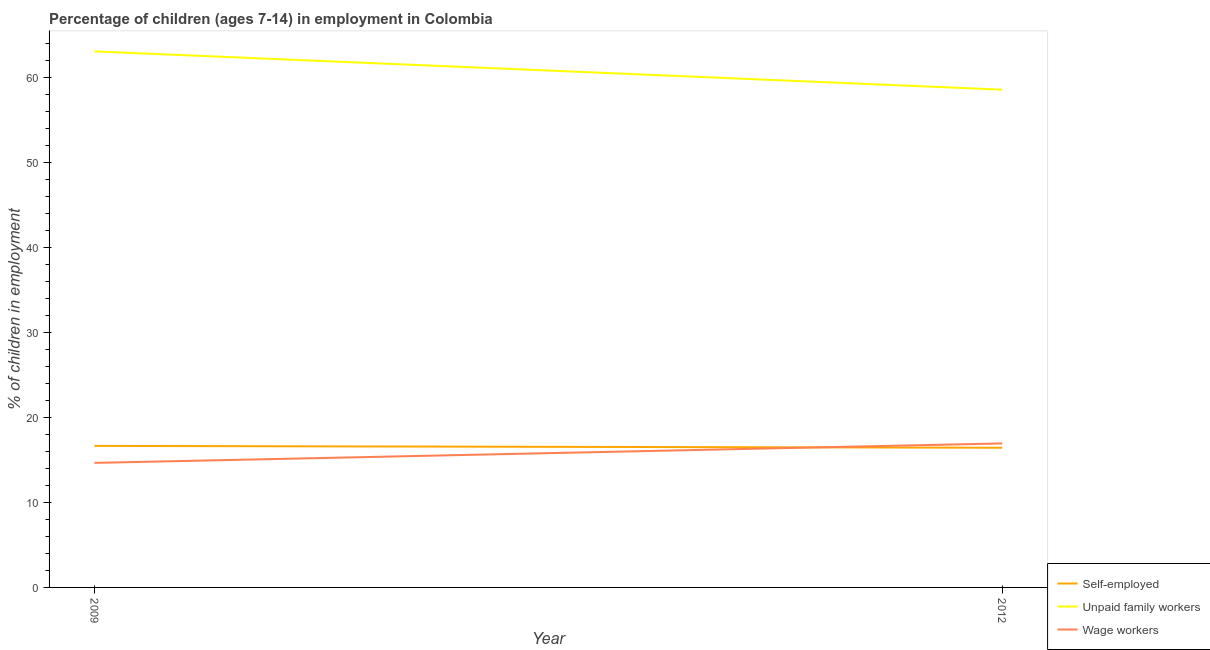Is the number of lines equal to the number of legend labels?
Provide a short and direct response. Yes. What is the percentage of self employed children in 2009?
Give a very brief answer. 16.64. Across all years, what is the maximum percentage of children employed as unpaid family workers?
Ensure brevity in your answer.  63.02. Across all years, what is the minimum percentage of children employed as unpaid family workers?
Provide a short and direct response. 58.52. What is the total percentage of children employed as unpaid family workers in the graph?
Offer a very short reply. 121.54. What is the difference between the percentage of self employed children in 2009 and that in 2012?
Your answer should be compact. 0.22. What is the difference between the percentage of children employed as wage workers in 2012 and the percentage of children employed as unpaid family workers in 2009?
Your response must be concise. -46.09. What is the average percentage of self employed children per year?
Make the answer very short. 16.53. In the year 2012, what is the difference between the percentage of children employed as unpaid family workers and percentage of children employed as wage workers?
Your response must be concise. 41.59. In how many years, is the percentage of self employed children greater than 2 %?
Your answer should be very brief. 2. What is the ratio of the percentage of children employed as wage workers in 2009 to that in 2012?
Your answer should be very brief. 0.86. Is the percentage of children employed as unpaid family workers in 2009 less than that in 2012?
Keep it short and to the point. No. Does the percentage of children employed as unpaid family workers monotonically increase over the years?
Keep it short and to the point. No. Is the percentage of children employed as wage workers strictly greater than the percentage of children employed as unpaid family workers over the years?
Give a very brief answer. No. How many years are there in the graph?
Offer a terse response. 2. Are the values on the major ticks of Y-axis written in scientific E-notation?
Keep it short and to the point. No. Does the graph contain any zero values?
Keep it short and to the point. No. Where does the legend appear in the graph?
Make the answer very short. Bottom right. How are the legend labels stacked?
Your answer should be compact. Vertical. What is the title of the graph?
Your response must be concise. Percentage of children (ages 7-14) in employment in Colombia. What is the label or title of the X-axis?
Your response must be concise. Year. What is the label or title of the Y-axis?
Your response must be concise. % of children in employment. What is the % of children in employment in Self-employed in 2009?
Your answer should be very brief. 16.64. What is the % of children in employment in Unpaid family workers in 2009?
Your answer should be very brief. 63.02. What is the % of children in employment in Wage workers in 2009?
Your response must be concise. 14.64. What is the % of children in employment in Self-employed in 2012?
Ensure brevity in your answer.  16.42. What is the % of children in employment of Unpaid family workers in 2012?
Keep it short and to the point. 58.52. What is the % of children in employment of Wage workers in 2012?
Offer a terse response. 16.93. Across all years, what is the maximum % of children in employment of Self-employed?
Give a very brief answer. 16.64. Across all years, what is the maximum % of children in employment of Unpaid family workers?
Your answer should be very brief. 63.02. Across all years, what is the maximum % of children in employment of Wage workers?
Provide a short and direct response. 16.93. Across all years, what is the minimum % of children in employment in Self-employed?
Provide a short and direct response. 16.42. Across all years, what is the minimum % of children in employment of Unpaid family workers?
Make the answer very short. 58.52. Across all years, what is the minimum % of children in employment in Wage workers?
Give a very brief answer. 14.64. What is the total % of children in employment of Self-employed in the graph?
Provide a succinct answer. 33.06. What is the total % of children in employment of Unpaid family workers in the graph?
Your answer should be compact. 121.54. What is the total % of children in employment in Wage workers in the graph?
Your answer should be compact. 31.57. What is the difference between the % of children in employment of Self-employed in 2009 and that in 2012?
Your answer should be compact. 0.22. What is the difference between the % of children in employment of Unpaid family workers in 2009 and that in 2012?
Your response must be concise. 4.5. What is the difference between the % of children in employment in Wage workers in 2009 and that in 2012?
Ensure brevity in your answer.  -2.29. What is the difference between the % of children in employment in Self-employed in 2009 and the % of children in employment in Unpaid family workers in 2012?
Provide a succinct answer. -41.88. What is the difference between the % of children in employment of Self-employed in 2009 and the % of children in employment of Wage workers in 2012?
Your answer should be very brief. -0.29. What is the difference between the % of children in employment in Unpaid family workers in 2009 and the % of children in employment in Wage workers in 2012?
Your answer should be compact. 46.09. What is the average % of children in employment in Self-employed per year?
Ensure brevity in your answer.  16.53. What is the average % of children in employment of Unpaid family workers per year?
Ensure brevity in your answer.  60.77. What is the average % of children in employment in Wage workers per year?
Offer a very short reply. 15.79. In the year 2009, what is the difference between the % of children in employment of Self-employed and % of children in employment of Unpaid family workers?
Give a very brief answer. -46.38. In the year 2009, what is the difference between the % of children in employment in Unpaid family workers and % of children in employment in Wage workers?
Offer a very short reply. 48.38. In the year 2012, what is the difference between the % of children in employment in Self-employed and % of children in employment in Unpaid family workers?
Your response must be concise. -42.1. In the year 2012, what is the difference between the % of children in employment of Self-employed and % of children in employment of Wage workers?
Your answer should be compact. -0.51. In the year 2012, what is the difference between the % of children in employment of Unpaid family workers and % of children in employment of Wage workers?
Keep it short and to the point. 41.59. What is the ratio of the % of children in employment of Self-employed in 2009 to that in 2012?
Offer a terse response. 1.01. What is the ratio of the % of children in employment in Unpaid family workers in 2009 to that in 2012?
Offer a very short reply. 1.08. What is the ratio of the % of children in employment in Wage workers in 2009 to that in 2012?
Your response must be concise. 0.86. What is the difference between the highest and the second highest % of children in employment in Self-employed?
Your answer should be compact. 0.22. What is the difference between the highest and the second highest % of children in employment in Wage workers?
Keep it short and to the point. 2.29. What is the difference between the highest and the lowest % of children in employment in Self-employed?
Make the answer very short. 0.22. What is the difference between the highest and the lowest % of children in employment in Unpaid family workers?
Your answer should be compact. 4.5. What is the difference between the highest and the lowest % of children in employment in Wage workers?
Keep it short and to the point. 2.29. 